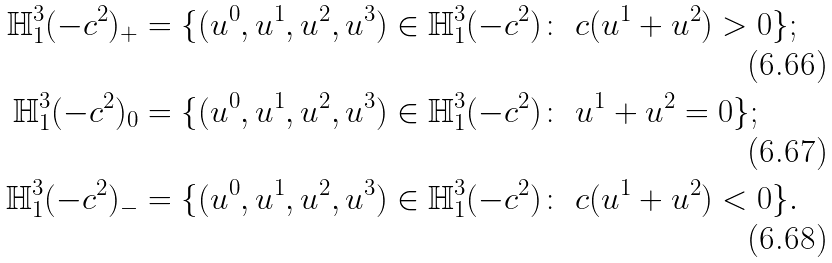<formula> <loc_0><loc_0><loc_500><loc_500>\mathbb { H } ^ { 3 } _ { 1 } ( - c ^ { 2 } ) _ { + } & = \{ ( u ^ { 0 } , u ^ { 1 } , u ^ { 2 } , u ^ { 3 } ) \in \mathbb { H } ^ { 3 } _ { 1 } ( - c ^ { 2 } ) \colon \ c ( u ^ { 1 } + u ^ { 2 } ) > 0 \} ; \\ \mathbb { H } ^ { 3 } _ { 1 } ( - c ^ { 2 } ) _ { 0 } & = \{ ( u ^ { 0 } , u ^ { 1 } , u ^ { 2 } , u ^ { 3 } ) \in \mathbb { H } ^ { 3 } _ { 1 } ( - c ^ { 2 } ) \colon \ u ^ { 1 } + u ^ { 2 } = 0 \} ; \\ \mathbb { H } ^ { 3 } _ { 1 } ( - c ^ { 2 } ) _ { - } & = \{ ( u ^ { 0 } , u ^ { 1 } , u ^ { 2 } , u ^ { 3 } ) \in \mathbb { H } ^ { 3 } _ { 1 } ( - c ^ { 2 } ) \colon \ c ( u ^ { 1 } + u ^ { 2 } ) < 0 \} .</formula> 